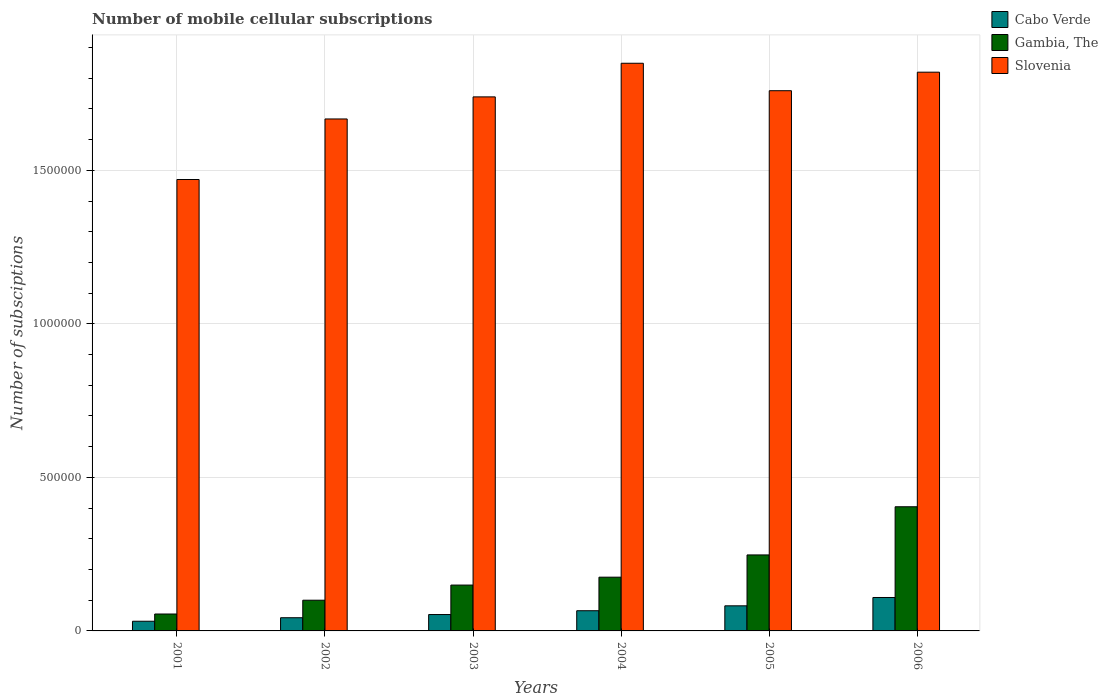Are the number of bars on each tick of the X-axis equal?
Make the answer very short. Yes. How many bars are there on the 2nd tick from the left?
Offer a terse response. 3. What is the label of the 4th group of bars from the left?
Keep it short and to the point. 2004. In how many cases, is the number of bars for a given year not equal to the number of legend labels?
Provide a short and direct response. 0. What is the number of mobile cellular subscriptions in Slovenia in 2001?
Offer a terse response. 1.47e+06. Across all years, what is the maximum number of mobile cellular subscriptions in Slovenia?
Provide a short and direct response. 1.85e+06. Across all years, what is the minimum number of mobile cellular subscriptions in Gambia, The?
Provide a short and direct response. 5.51e+04. In which year was the number of mobile cellular subscriptions in Slovenia minimum?
Ensure brevity in your answer.  2001. What is the total number of mobile cellular subscriptions in Slovenia in the graph?
Keep it short and to the point. 1.03e+07. What is the difference between the number of mobile cellular subscriptions in Cabo Verde in 2004 and that in 2005?
Make the answer very short. -1.59e+04. What is the difference between the number of mobile cellular subscriptions in Cabo Verde in 2002 and the number of mobile cellular subscriptions in Slovenia in 2004?
Make the answer very short. -1.81e+06. What is the average number of mobile cellular subscriptions in Gambia, The per year?
Provide a short and direct response. 1.89e+05. In the year 2002, what is the difference between the number of mobile cellular subscriptions in Slovenia and number of mobile cellular subscriptions in Cabo Verde?
Offer a terse response. 1.62e+06. What is the ratio of the number of mobile cellular subscriptions in Cabo Verde in 2001 to that in 2004?
Your answer should be compact. 0.48. Is the number of mobile cellular subscriptions in Gambia, The in 2001 less than that in 2004?
Offer a very short reply. Yes. Is the difference between the number of mobile cellular subscriptions in Slovenia in 2002 and 2004 greater than the difference between the number of mobile cellular subscriptions in Cabo Verde in 2002 and 2004?
Make the answer very short. No. What is the difference between the highest and the second highest number of mobile cellular subscriptions in Cabo Verde?
Make the answer very short. 2.71e+04. What is the difference between the highest and the lowest number of mobile cellular subscriptions in Slovenia?
Keep it short and to the point. 3.79e+05. In how many years, is the number of mobile cellular subscriptions in Slovenia greater than the average number of mobile cellular subscriptions in Slovenia taken over all years?
Give a very brief answer. 4. What does the 3rd bar from the left in 2006 represents?
Provide a succinct answer. Slovenia. What does the 3rd bar from the right in 2003 represents?
Offer a terse response. Cabo Verde. How many bars are there?
Ensure brevity in your answer.  18. Are all the bars in the graph horizontal?
Offer a terse response. No. What is the difference between two consecutive major ticks on the Y-axis?
Keep it short and to the point. 5.00e+05. Does the graph contain any zero values?
Give a very brief answer. No. Does the graph contain grids?
Your response must be concise. Yes. How many legend labels are there?
Your answer should be very brief. 3. How are the legend labels stacked?
Your answer should be very brief. Vertical. What is the title of the graph?
Provide a succinct answer. Number of mobile cellular subscriptions. Does "American Samoa" appear as one of the legend labels in the graph?
Make the answer very short. No. What is the label or title of the Y-axis?
Your answer should be very brief. Number of subsciptions. What is the Number of subsciptions in Cabo Verde in 2001?
Offer a very short reply. 3.15e+04. What is the Number of subsciptions of Gambia, The in 2001?
Provide a succinct answer. 5.51e+04. What is the Number of subsciptions in Slovenia in 2001?
Your answer should be very brief. 1.47e+06. What is the Number of subsciptions of Cabo Verde in 2002?
Your response must be concise. 4.29e+04. What is the Number of subsciptions in Gambia, The in 2002?
Keep it short and to the point. 1.00e+05. What is the Number of subsciptions of Slovenia in 2002?
Offer a very short reply. 1.67e+06. What is the Number of subsciptions in Cabo Verde in 2003?
Your response must be concise. 5.33e+04. What is the Number of subsciptions of Gambia, The in 2003?
Give a very brief answer. 1.49e+05. What is the Number of subsciptions of Slovenia in 2003?
Your response must be concise. 1.74e+06. What is the Number of subsciptions of Cabo Verde in 2004?
Make the answer very short. 6.58e+04. What is the Number of subsciptions in Gambia, The in 2004?
Provide a short and direct response. 1.75e+05. What is the Number of subsciptions in Slovenia in 2004?
Your answer should be compact. 1.85e+06. What is the Number of subsciptions in Cabo Verde in 2005?
Make the answer very short. 8.17e+04. What is the Number of subsciptions of Gambia, The in 2005?
Keep it short and to the point. 2.47e+05. What is the Number of subsciptions in Slovenia in 2005?
Your response must be concise. 1.76e+06. What is the Number of subsciptions in Cabo Verde in 2006?
Offer a terse response. 1.09e+05. What is the Number of subsciptions of Gambia, The in 2006?
Give a very brief answer. 4.04e+05. What is the Number of subsciptions of Slovenia in 2006?
Give a very brief answer. 1.82e+06. Across all years, what is the maximum Number of subsciptions of Cabo Verde?
Your answer should be very brief. 1.09e+05. Across all years, what is the maximum Number of subsciptions of Gambia, The?
Make the answer very short. 4.04e+05. Across all years, what is the maximum Number of subsciptions of Slovenia?
Give a very brief answer. 1.85e+06. Across all years, what is the minimum Number of subsciptions in Cabo Verde?
Offer a terse response. 3.15e+04. Across all years, what is the minimum Number of subsciptions of Gambia, The?
Give a very brief answer. 5.51e+04. Across all years, what is the minimum Number of subsciptions in Slovenia?
Ensure brevity in your answer.  1.47e+06. What is the total Number of subsciptions of Cabo Verde in the graph?
Offer a terse response. 3.84e+05. What is the total Number of subsciptions in Gambia, The in the graph?
Ensure brevity in your answer.  1.13e+06. What is the total Number of subsciptions of Slovenia in the graph?
Offer a very short reply. 1.03e+07. What is the difference between the Number of subsciptions in Cabo Verde in 2001 and that in 2002?
Give a very brief answer. -1.14e+04. What is the difference between the Number of subsciptions in Gambia, The in 2001 and that in 2002?
Your response must be concise. -4.49e+04. What is the difference between the Number of subsciptions of Slovenia in 2001 and that in 2002?
Your answer should be compact. -1.97e+05. What is the difference between the Number of subsciptions of Cabo Verde in 2001 and that in 2003?
Keep it short and to the point. -2.18e+04. What is the difference between the Number of subsciptions in Gambia, The in 2001 and that in 2003?
Your answer should be compact. -9.42e+04. What is the difference between the Number of subsciptions in Slovenia in 2001 and that in 2003?
Provide a succinct answer. -2.69e+05. What is the difference between the Number of subsciptions of Cabo Verde in 2001 and that in 2004?
Provide a short and direct response. -3.43e+04. What is the difference between the Number of subsciptions of Gambia, The in 2001 and that in 2004?
Your answer should be compact. -1.20e+05. What is the difference between the Number of subsciptions in Slovenia in 2001 and that in 2004?
Provide a short and direct response. -3.79e+05. What is the difference between the Number of subsciptions in Cabo Verde in 2001 and that in 2005?
Your answer should be very brief. -5.02e+04. What is the difference between the Number of subsciptions of Gambia, The in 2001 and that in 2005?
Offer a very short reply. -1.92e+05. What is the difference between the Number of subsciptions in Slovenia in 2001 and that in 2005?
Offer a very short reply. -2.89e+05. What is the difference between the Number of subsciptions of Cabo Verde in 2001 and that in 2006?
Your answer should be very brief. -7.74e+04. What is the difference between the Number of subsciptions of Gambia, The in 2001 and that in 2006?
Offer a terse response. -3.49e+05. What is the difference between the Number of subsciptions of Slovenia in 2001 and that in 2006?
Ensure brevity in your answer.  -3.49e+05. What is the difference between the Number of subsciptions of Cabo Verde in 2002 and that in 2003?
Ensure brevity in your answer.  -1.04e+04. What is the difference between the Number of subsciptions in Gambia, The in 2002 and that in 2003?
Provide a short and direct response. -4.93e+04. What is the difference between the Number of subsciptions in Slovenia in 2002 and that in 2003?
Keep it short and to the point. -7.19e+04. What is the difference between the Number of subsciptions in Cabo Verde in 2002 and that in 2004?
Offer a terse response. -2.28e+04. What is the difference between the Number of subsciptions in Gambia, The in 2002 and that in 2004?
Ensure brevity in your answer.  -7.50e+04. What is the difference between the Number of subsciptions of Slovenia in 2002 and that in 2004?
Your response must be concise. -1.81e+05. What is the difference between the Number of subsciptions of Cabo Verde in 2002 and that in 2005?
Give a very brief answer. -3.88e+04. What is the difference between the Number of subsciptions in Gambia, The in 2002 and that in 2005?
Give a very brief answer. -1.47e+05. What is the difference between the Number of subsciptions in Slovenia in 2002 and that in 2005?
Make the answer very short. -9.20e+04. What is the difference between the Number of subsciptions in Cabo Verde in 2002 and that in 2006?
Keep it short and to the point. -6.59e+04. What is the difference between the Number of subsciptions in Gambia, The in 2002 and that in 2006?
Offer a terse response. -3.04e+05. What is the difference between the Number of subsciptions of Slovenia in 2002 and that in 2006?
Keep it short and to the point. -1.52e+05. What is the difference between the Number of subsciptions in Cabo Verde in 2003 and that in 2004?
Offer a very short reply. -1.24e+04. What is the difference between the Number of subsciptions in Gambia, The in 2003 and that in 2004?
Your response must be concise. -2.57e+04. What is the difference between the Number of subsciptions in Slovenia in 2003 and that in 2004?
Offer a very short reply. -1.09e+05. What is the difference between the Number of subsciptions of Cabo Verde in 2003 and that in 2005?
Give a very brief answer. -2.84e+04. What is the difference between the Number of subsciptions in Gambia, The in 2003 and that in 2005?
Make the answer very short. -9.82e+04. What is the difference between the Number of subsciptions of Slovenia in 2003 and that in 2005?
Provide a short and direct response. -2.01e+04. What is the difference between the Number of subsciptions in Cabo Verde in 2003 and that in 2006?
Ensure brevity in your answer.  -5.55e+04. What is the difference between the Number of subsciptions in Gambia, The in 2003 and that in 2006?
Your answer should be compact. -2.55e+05. What is the difference between the Number of subsciptions of Slovenia in 2003 and that in 2006?
Offer a very short reply. -8.04e+04. What is the difference between the Number of subsciptions in Cabo Verde in 2004 and that in 2005?
Offer a terse response. -1.59e+04. What is the difference between the Number of subsciptions in Gambia, The in 2004 and that in 2005?
Your answer should be compact. -7.25e+04. What is the difference between the Number of subsciptions in Slovenia in 2004 and that in 2005?
Your answer should be compact. 8.94e+04. What is the difference between the Number of subsciptions in Cabo Verde in 2004 and that in 2006?
Offer a terse response. -4.31e+04. What is the difference between the Number of subsciptions in Gambia, The in 2004 and that in 2006?
Your answer should be compact. -2.29e+05. What is the difference between the Number of subsciptions in Slovenia in 2004 and that in 2006?
Keep it short and to the point. 2.91e+04. What is the difference between the Number of subsciptions in Cabo Verde in 2005 and that in 2006?
Ensure brevity in your answer.  -2.71e+04. What is the difference between the Number of subsciptions of Gambia, The in 2005 and that in 2006?
Offer a terse response. -1.57e+05. What is the difference between the Number of subsciptions in Slovenia in 2005 and that in 2006?
Offer a terse response. -6.03e+04. What is the difference between the Number of subsciptions in Cabo Verde in 2001 and the Number of subsciptions in Gambia, The in 2002?
Your answer should be compact. -6.85e+04. What is the difference between the Number of subsciptions of Cabo Verde in 2001 and the Number of subsciptions of Slovenia in 2002?
Your answer should be very brief. -1.64e+06. What is the difference between the Number of subsciptions of Gambia, The in 2001 and the Number of subsciptions of Slovenia in 2002?
Keep it short and to the point. -1.61e+06. What is the difference between the Number of subsciptions in Cabo Verde in 2001 and the Number of subsciptions in Gambia, The in 2003?
Offer a very short reply. -1.18e+05. What is the difference between the Number of subsciptions in Cabo Verde in 2001 and the Number of subsciptions in Slovenia in 2003?
Keep it short and to the point. -1.71e+06. What is the difference between the Number of subsciptions of Gambia, The in 2001 and the Number of subsciptions of Slovenia in 2003?
Keep it short and to the point. -1.68e+06. What is the difference between the Number of subsciptions of Cabo Verde in 2001 and the Number of subsciptions of Gambia, The in 2004?
Provide a succinct answer. -1.43e+05. What is the difference between the Number of subsciptions in Cabo Verde in 2001 and the Number of subsciptions in Slovenia in 2004?
Your response must be concise. -1.82e+06. What is the difference between the Number of subsciptions of Gambia, The in 2001 and the Number of subsciptions of Slovenia in 2004?
Offer a terse response. -1.79e+06. What is the difference between the Number of subsciptions of Cabo Verde in 2001 and the Number of subsciptions of Gambia, The in 2005?
Your answer should be very brief. -2.16e+05. What is the difference between the Number of subsciptions in Cabo Verde in 2001 and the Number of subsciptions in Slovenia in 2005?
Provide a short and direct response. -1.73e+06. What is the difference between the Number of subsciptions in Gambia, The in 2001 and the Number of subsciptions in Slovenia in 2005?
Offer a very short reply. -1.70e+06. What is the difference between the Number of subsciptions of Cabo Verde in 2001 and the Number of subsciptions of Gambia, The in 2006?
Offer a terse response. -3.73e+05. What is the difference between the Number of subsciptions of Cabo Verde in 2001 and the Number of subsciptions of Slovenia in 2006?
Make the answer very short. -1.79e+06. What is the difference between the Number of subsciptions in Gambia, The in 2001 and the Number of subsciptions in Slovenia in 2006?
Your response must be concise. -1.76e+06. What is the difference between the Number of subsciptions in Cabo Verde in 2002 and the Number of subsciptions in Gambia, The in 2003?
Your answer should be compact. -1.06e+05. What is the difference between the Number of subsciptions of Cabo Verde in 2002 and the Number of subsciptions of Slovenia in 2003?
Provide a short and direct response. -1.70e+06. What is the difference between the Number of subsciptions in Gambia, The in 2002 and the Number of subsciptions in Slovenia in 2003?
Ensure brevity in your answer.  -1.64e+06. What is the difference between the Number of subsciptions in Cabo Verde in 2002 and the Number of subsciptions in Gambia, The in 2004?
Make the answer very short. -1.32e+05. What is the difference between the Number of subsciptions of Cabo Verde in 2002 and the Number of subsciptions of Slovenia in 2004?
Your answer should be compact. -1.81e+06. What is the difference between the Number of subsciptions in Gambia, The in 2002 and the Number of subsciptions in Slovenia in 2004?
Offer a very short reply. -1.75e+06. What is the difference between the Number of subsciptions of Cabo Verde in 2002 and the Number of subsciptions of Gambia, The in 2005?
Keep it short and to the point. -2.05e+05. What is the difference between the Number of subsciptions in Cabo Verde in 2002 and the Number of subsciptions in Slovenia in 2005?
Your answer should be very brief. -1.72e+06. What is the difference between the Number of subsciptions in Gambia, The in 2002 and the Number of subsciptions in Slovenia in 2005?
Keep it short and to the point. -1.66e+06. What is the difference between the Number of subsciptions in Cabo Verde in 2002 and the Number of subsciptions in Gambia, The in 2006?
Your answer should be compact. -3.61e+05. What is the difference between the Number of subsciptions of Cabo Verde in 2002 and the Number of subsciptions of Slovenia in 2006?
Ensure brevity in your answer.  -1.78e+06. What is the difference between the Number of subsciptions of Gambia, The in 2002 and the Number of subsciptions of Slovenia in 2006?
Offer a terse response. -1.72e+06. What is the difference between the Number of subsciptions in Cabo Verde in 2003 and the Number of subsciptions in Gambia, The in 2004?
Your answer should be very brief. -1.22e+05. What is the difference between the Number of subsciptions of Cabo Verde in 2003 and the Number of subsciptions of Slovenia in 2004?
Your response must be concise. -1.80e+06. What is the difference between the Number of subsciptions in Gambia, The in 2003 and the Number of subsciptions in Slovenia in 2004?
Make the answer very short. -1.70e+06. What is the difference between the Number of subsciptions of Cabo Verde in 2003 and the Number of subsciptions of Gambia, The in 2005?
Your answer should be very brief. -1.94e+05. What is the difference between the Number of subsciptions of Cabo Verde in 2003 and the Number of subsciptions of Slovenia in 2005?
Make the answer very short. -1.71e+06. What is the difference between the Number of subsciptions in Gambia, The in 2003 and the Number of subsciptions in Slovenia in 2005?
Your answer should be compact. -1.61e+06. What is the difference between the Number of subsciptions in Cabo Verde in 2003 and the Number of subsciptions in Gambia, The in 2006?
Your response must be concise. -3.51e+05. What is the difference between the Number of subsciptions in Cabo Verde in 2003 and the Number of subsciptions in Slovenia in 2006?
Ensure brevity in your answer.  -1.77e+06. What is the difference between the Number of subsciptions of Gambia, The in 2003 and the Number of subsciptions of Slovenia in 2006?
Provide a short and direct response. -1.67e+06. What is the difference between the Number of subsciptions in Cabo Verde in 2004 and the Number of subsciptions in Gambia, The in 2005?
Your answer should be very brief. -1.82e+05. What is the difference between the Number of subsciptions in Cabo Verde in 2004 and the Number of subsciptions in Slovenia in 2005?
Give a very brief answer. -1.69e+06. What is the difference between the Number of subsciptions of Gambia, The in 2004 and the Number of subsciptions of Slovenia in 2005?
Keep it short and to the point. -1.58e+06. What is the difference between the Number of subsciptions in Cabo Verde in 2004 and the Number of subsciptions in Gambia, The in 2006?
Your answer should be compact. -3.39e+05. What is the difference between the Number of subsciptions in Cabo Verde in 2004 and the Number of subsciptions in Slovenia in 2006?
Keep it short and to the point. -1.75e+06. What is the difference between the Number of subsciptions of Gambia, The in 2004 and the Number of subsciptions of Slovenia in 2006?
Make the answer very short. -1.64e+06. What is the difference between the Number of subsciptions in Cabo Verde in 2005 and the Number of subsciptions in Gambia, The in 2006?
Provide a succinct answer. -3.23e+05. What is the difference between the Number of subsciptions of Cabo Verde in 2005 and the Number of subsciptions of Slovenia in 2006?
Give a very brief answer. -1.74e+06. What is the difference between the Number of subsciptions in Gambia, The in 2005 and the Number of subsciptions in Slovenia in 2006?
Provide a succinct answer. -1.57e+06. What is the average Number of subsciptions in Cabo Verde per year?
Offer a very short reply. 6.40e+04. What is the average Number of subsciptions in Gambia, The per year?
Your answer should be compact. 1.89e+05. What is the average Number of subsciptions in Slovenia per year?
Your answer should be very brief. 1.72e+06. In the year 2001, what is the difference between the Number of subsciptions in Cabo Verde and Number of subsciptions in Gambia, The?
Ensure brevity in your answer.  -2.36e+04. In the year 2001, what is the difference between the Number of subsciptions of Cabo Verde and Number of subsciptions of Slovenia?
Give a very brief answer. -1.44e+06. In the year 2001, what is the difference between the Number of subsciptions in Gambia, The and Number of subsciptions in Slovenia?
Keep it short and to the point. -1.42e+06. In the year 2002, what is the difference between the Number of subsciptions in Cabo Verde and Number of subsciptions in Gambia, The?
Offer a very short reply. -5.71e+04. In the year 2002, what is the difference between the Number of subsciptions of Cabo Verde and Number of subsciptions of Slovenia?
Keep it short and to the point. -1.62e+06. In the year 2002, what is the difference between the Number of subsciptions in Gambia, The and Number of subsciptions in Slovenia?
Provide a short and direct response. -1.57e+06. In the year 2003, what is the difference between the Number of subsciptions of Cabo Verde and Number of subsciptions of Gambia, The?
Your answer should be very brief. -9.60e+04. In the year 2003, what is the difference between the Number of subsciptions in Cabo Verde and Number of subsciptions in Slovenia?
Offer a very short reply. -1.69e+06. In the year 2003, what is the difference between the Number of subsciptions in Gambia, The and Number of subsciptions in Slovenia?
Provide a succinct answer. -1.59e+06. In the year 2004, what is the difference between the Number of subsciptions of Cabo Verde and Number of subsciptions of Gambia, The?
Make the answer very short. -1.09e+05. In the year 2004, what is the difference between the Number of subsciptions in Cabo Verde and Number of subsciptions in Slovenia?
Give a very brief answer. -1.78e+06. In the year 2004, what is the difference between the Number of subsciptions in Gambia, The and Number of subsciptions in Slovenia?
Your response must be concise. -1.67e+06. In the year 2005, what is the difference between the Number of subsciptions of Cabo Verde and Number of subsciptions of Gambia, The?
Ensure brevity in your answer.  -1.66e+05. In the year 2005, what is the difference between the Number of subsciptions of Cabo Verde and Number of subsciptions of Slovenia?
Your answer should be very brief. -1.68e+06. In the year 2005, what is the difference between the Number of subsciptions in Gambia, The and Number of subsciptions in Slovenia?
Give a very brief answer. -1.51e+06. In the year 2006, what is the difference between the Number of subsciptions of Cabo Verde and Number of subsciptions of Gambia, The?
Your response must be concise. -2.95e+05. In the year 2006, what is the difference between the Number of subsciptions in Cabo Verde and Number of subsciptions in Slovenia?
Provide a short and direct response. -1.71e+06. In the year 2006, what is the difference between the Number of subsciptions of Gambia, The and Number of subsciptions of Slovenia?
Provide a short and direct response. -1.42e+06. What is the ratio of the Number of subsciptions of Cabo Verde in 2001 to that in 2002?
Your answer should be compact. 0.73. What is the ratio of the Number of subsciptions in Gambia, The in 2001 to that in 2002?
Your response must be concise. 0.55. What is the ratio of the Number of subsciptions in Slovenia in 2001 to that in 2002?
Your answer should be very brief. 0.88. What is the ratio of the Number of subsciptions of Cabo Verde in 2001 to that in 2003?
Offer a terse response. 0.59. What is the ratio of the Number of subsciptions in Gambia, The in 2001 to that in 2003?
Provide a succinct answer. 0.37. What is the ratio of the Number of subsciptions of Slovenia in 2001 to that in 2003?
Your answer should be compact. 0.85. What is the ratio of the Number of subsciptions in Cabo Verde in 2001 to that in 2004?
Your response must be concise. 0.48. What is the ratio of the Number of subsciptions in Gambia, The in 2001 to that in 2004?
Your answer should be very brief. 0.31. What is the ratio of the Number of subsciptions in Slovenia in 2001 to that in 2004?
Give a very brief answer. 0.8. What is the ratio of the Number of subsciptions of Cabo Verde in 2001 to that in 2005?
Provide a succinct answer. 0.39. What is the ratio of the Number of subsciptions in Gambia, The in 2001 to that in 2005?
Ensure brevity in your answer.  0.22. What is the ratio of the Number of subsciptions of Slovenia in 2001 to that in 2005?
Offer a terse response. 0.84. What is the ratio of the Number of subsciptions in Cabo Verde in 2001 to that in 2006?
Offer a very short reply. 0.29. What is the ratio of the Number of subsciptions in Gambia, The in 2001 to that in 2006?
Your answer should be compact. 0.14. What is the ratio of the Number of subsciptions of Slovenia in 2001 to that in 2006?
Your response must be concise. 0.81. What is the ratio of the Number of subsciptions of Cabo Verde in 2002 to that in 2003?
Offer a terse response. 0.81. What is the ratio of the Number of subsciptions in Gambia, The in 2002 to that in 2003?
Offer a very short reply. 0.67. What is the ratio of the Number of subsciptions of Slovenia in 2002 to that in 2003?
Give a very brief answer. 0.96. What is the ratio of the Number of subsciptions of Cabo Verde in 2002 to that in 2004?
Ensure brevity in your answer.  0.65. What is the ratio of the Number of subsciptions in Slovenia in 2002 to that in 2004?
Offer a terse response. 0.9. What is the ratio of the Number of subsciptions in Cabo Verde in 2002 to that in 2005?
Your response must be concise. 0.53. What is the ratio of the Number of subsciptions of Gambia, The in 2002 to that in 2005?
Your answer should be very brief. 0.4. What is the ratio of the Number of subsciptions of Slovenia in 2002 to that in 2005?
Keep it short and to the point. 0.95. What is the ratio of the Number of subsciptions in Cabo Verde in 2002 to that in 2006?
Keep it short and to the point. 0.39. What is the ratio of the Number of subsciptions in Gambia, The in 2002 to that in 2006?
Your answer should be compact. 0.25. What is the ratio of the Number of subsciptions of Slovenia in 2002 to that in 2006?
Keep it short and to the point. 0.92. What is the ratio of the Number of subsciptions in Cabo Verde in 2003 to that in 2004?
Provide a succinct answer. 0.81. What is the ratio of the Number of subsciptions of Gambia, The in 2003 to that in 2004?
Give a very brief answer. 0.85. What is the ratio of the Number of subsciptions of Slovenia in 2003 to that in 2004?
Your answer should be very brief. 0.94. What is the ratio of the Number of subsciptions of Cabo Verde in 2003 to that in 2005?
Your answer should be compact. 0.65. What is the ratio of the Number of subsciptions of Gambia, The in 2003 to that in 2005?
Make the answer very short. 0.6. What is the ratio of the Number of subsciptions of Cabo Verde in 2003 to that in 2006?
Your response must be concise. 0.49. What is the ratio of the Number of subsciptions in Gambia, The in 2003 to that in 2006?
Provide a short and direct response. 0.37. What is the ratio of the Number of subsciptions of Slovenia in 2003 to that in 2006?
Your answer should be very brief. 0.96. What is the ratio of the Number of subsciptions of Cabo Verde in 2004 to that in 2005?
Provide a succinct answer. 0.8. What is the ratio of the Number of subsciptions of Gambia, The in 2004 to that in 2005?
Keep it short and to the point. 0.71. What is the ratio of the Number of subsciptions in Slovenia in 2004 to that in 2005?
Make the answer very short. 1.05. What is the ratio of the Number of subsciptions of Cabo Verde in 2004 to that in 2006?
Offer a very short reply. 0.6. What is the ratio of the Number of subsciptions in Gambia, The in 2004 to that in 2006?
Provide a short and direct response. 0.43. What is the ratio of the Number of subsciptions in Slovenia in 2004 to that in 2006?
Keep it short and to the point. 1.02. What is the ratio of the Number of subsciptions of Cabo Verde in 2005 to that in 2006?
Your answer should be very brief. 0.75. What is the ratio of the Number of subsciptions of Gambia, The in 2005 to that in 2006?
Provide a succinct answer. 0.61. What is the ratio of the Number of subsciptions in Slovenia in 2005 to that in 2006?
Give a very brief answer. 0.97. What is the difference between the highest and the second highest Number of subsciptions of Cabo Verde?
Your answer should be very brief. 2.71e+04. What is the difference between the highest and the second highest Number of subsciptions of Gambia, The?
Keep it short and to the point. 1.57e+05. What is the difference between the highest and the second highest Number of subsciptions in Slovenia?
Make the answer very short. 2.91e+04. What is the difference between the highest and the lowest Number of subsciptions in Cabo Verde?
Your answer should be compact. 7.74e+04. What is the difference between the highest and the lowest Number of subsciptions in Gambia, The?
Give a very brief answer. 3.49e+05. What is the difference between the highest and the lowest Number of subsciptions of Slovenia?
Offer a terse response. 3.79e+05. 